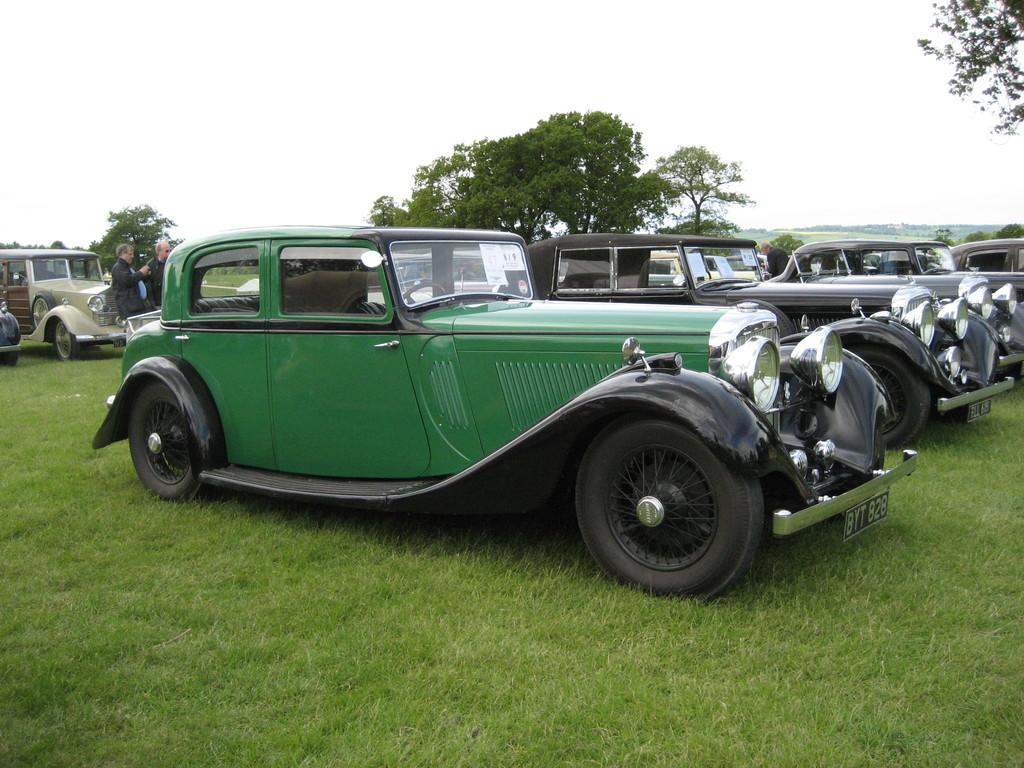What types of objects can be seen in the image? There are vehicles in the image. What else can be seen in the image besides vehicles? There are people standing in the image. What type of natural environment is visible in the image? There is grass visible in the image. What can be seen in the background of the image? There are trees and the sky visible in the background of the image. What type of root can be seen growing from the vehicles in the image? There are no roots visible in the image, and the vehicles are not growing anything. 